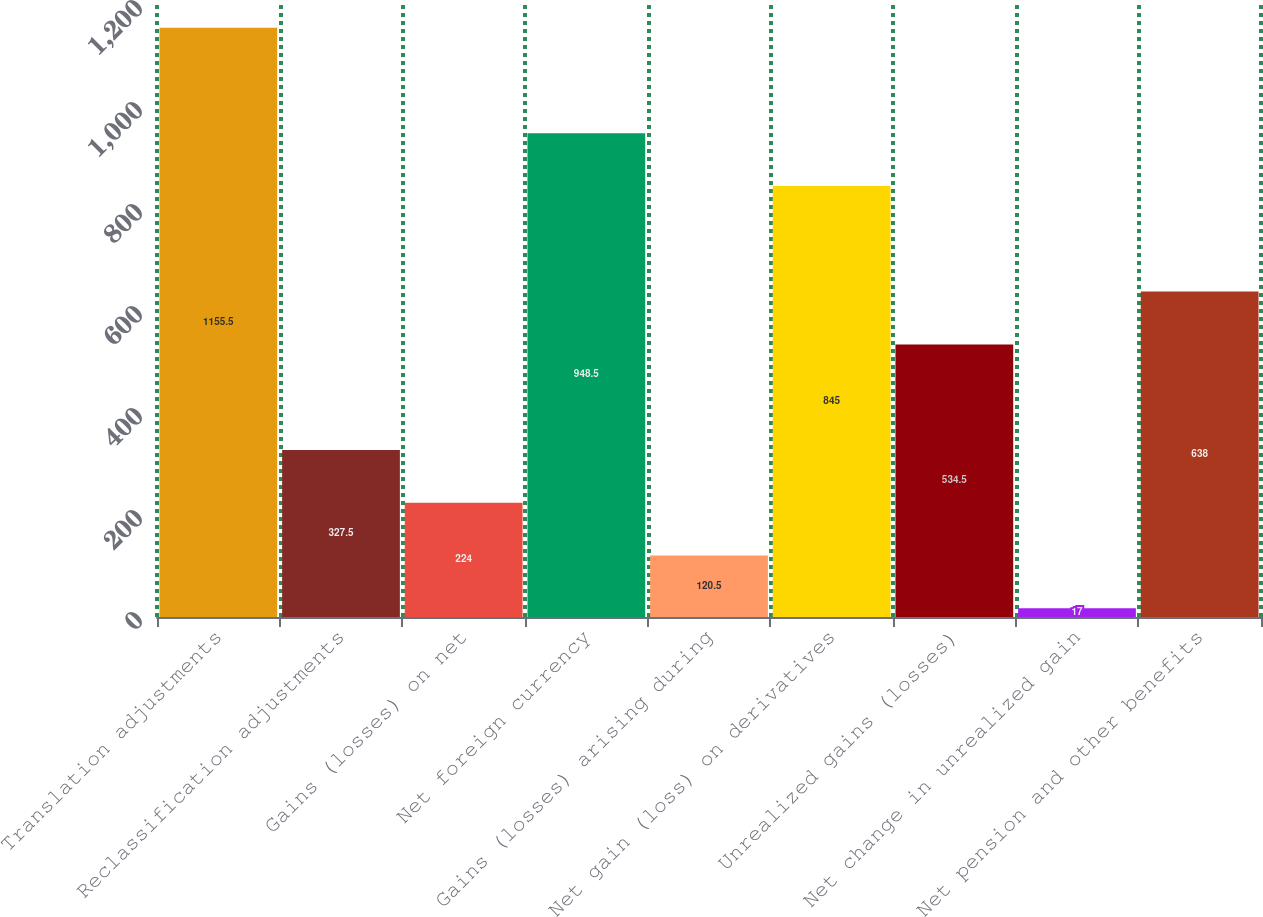Convert chart to OTSL. <chart><loc_0><loc_0><loc_500><loc_500><bar_chart><fcel>Translation adjustments<fcel>Reclassification adjustments<fcel>Gains (losses) on net<fcel>Net foreign currency<fcel>Gains (losses) arising during<fcel>Net gain (loss) on derivatives<fcel>Unrealized gains (losses)<fcel>Net change in unrealized gain<fcel>Net pension and other benefits<nl><fcel>1155.5<fcel>327.5<fcel>224<fcel>948.5<fcel>120.5<fcel>845<fcel>534.5<fcel>17<fcel>638<nl></chart> 